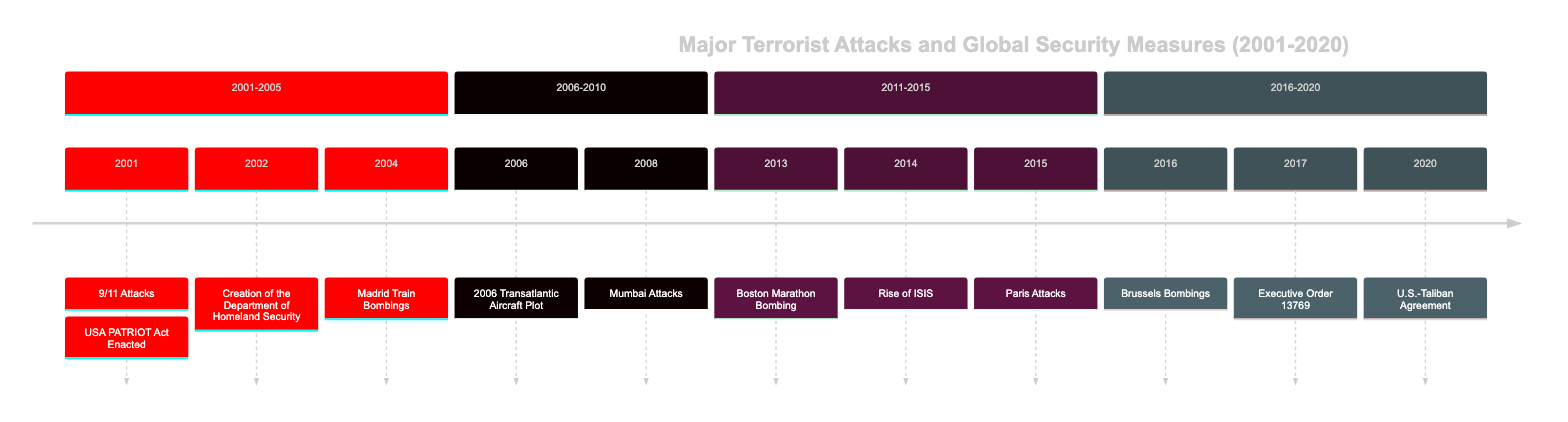What is the first event in the timeline? The timeline begins with the event on 9/11, which refers to the coordinated terrorist attacks by al-Qaeda. This event is labeled as the first occurrence in the year 2001.
Answer: 9/11 Attacks How many events occurred between 2001 and 2005? In the timeline segment for 2001-2005, there are four events listed: 9/11 Attacks, USA PATRIOT Act Enacted, Creation of the Department of Homeland Security, and Madrid Train Bombings. Counting these gives a total of four events.
Answer: 4 What legislation was enacted on October 26, 2001? The event recorded for October 26, 2001, is the enactment of the USA PATRIOT Act, which is explicitly stated in the timeline for that date.
Answer: USA PATRIOT Act Enacted Which event directly followed the Mumbai Attacks in 2008? The timeline shows that the event following the Mumbai Attacks in 2008 is the Boston Marathon Bombing, which occurred in 2013. This requires looking at the sequential order of events listed.
Answer: Boston Marathon Bombing What significant global response occurred after the Paris Attacks? The aftermath of the Paris Attacks in November 2015 led to a state of emergency and the implementation of new EU-wide security measures, indicating a strengthened security response at the European level.
Answer: New EU-wide security measures Which event prompted the creation of the Department of Homeland Security? The creation of the Department of Homeland Security was a direct response to the 9/11 attacks, intended to enhance national security and prevent future terrorism. This relationship is direct and highlighted in the timeline.
Answer: 9/11 Attacks What is a common theme among the events listed from 2014 onwards? The events from 2014 onward, including the rise of ISIS and the Paris attacks, share a common theme of increasing global terrorism threats that prompted heightened military responses and security measures across nations.
Answer: Increasing global terrorism threats How many total attacks were recorded in the timeline? By reviewing each entry in the timeline, one can count the number of specific terrorist attacks listed, including the 9/11 attacks, Madrid Train Bombings, Mumbai Attacks, Boston Marathon Bombing, Paris Attacks, and Brussels Bombings for a total of six attacks.
Answer: 6 